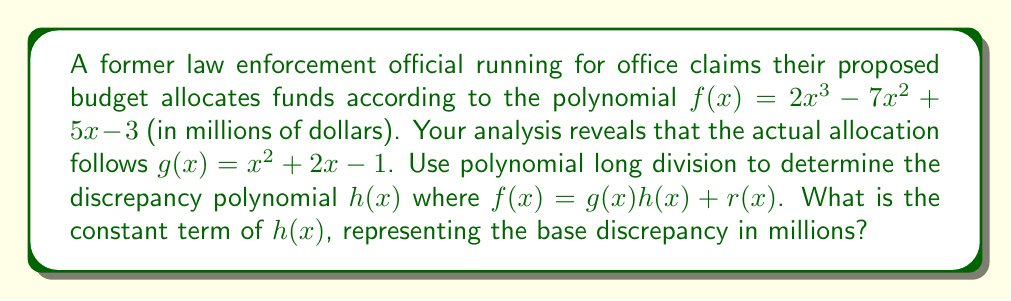Can you answer this question? Let's perform polynomial long division of $f(x)$ by $g(x)$ to find $h(x)$ and $r(x)$:

$$\begin{array}{r}
2x - 9 \\
x^2 + 2x - 1 \enclose{longdiv}{2x^3 - 7x^2 + 5x - 3} \\
\underline{2x^3 + 4x^2 - 2x} \\
-11x^2 + 7x \\
\underline{-11x^2 - 22x + 11} \\
29x - 14 \\
\underline{29x + 58 - 29} \\
-72 + 29 = -43
\end{array}$$

Therefore:
$h(x) = 2x - 9$
$r(x) = -43$

The polynomial division results in:
$f(x) = g(x)(2x - 9) + (-43)$

The constant term of $h(x)$ is -9.
Answer: -9 